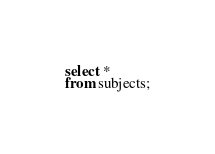Convert code to text. <code><loc_0><loc_0><loc_500><loc_500><_SQL_>select *
from subjects;
</code> 